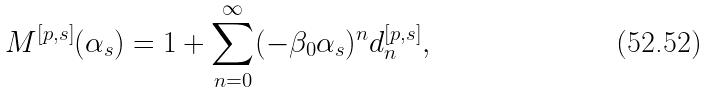<formula> <loc_0><loc_0><loc_500><loc_500>M ^ { [ p , s ] } ( \alpha _ { s } ) = 1 + \sum _ { n = 0 } ^ { \infty } ( - \beta _ { 0 } \alpha _ { s } ) ^ { n } d _ { n } ^ { [ p , s ] } ,</formula> 